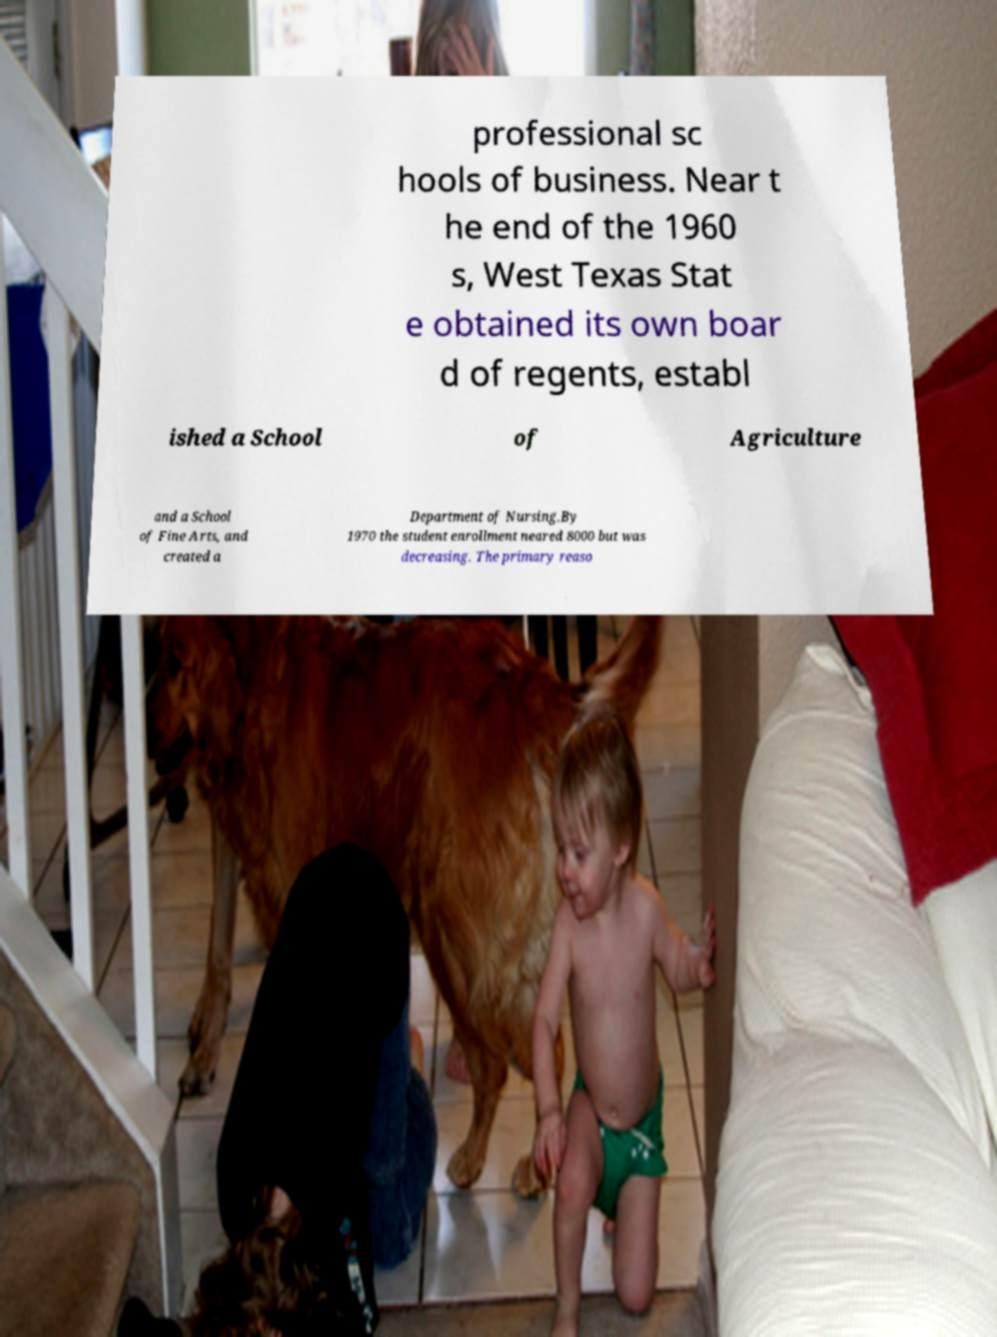What messages or text are displayed in this image? I need them in a readable, typed format. professional sc hools of business. Near t he end of the 1960 s, West Texas Stat e obtained its own boar d of regents, establ ished a School of Agriculture and a School of Fine Arts, and created a Department of Nursing.By 1970 the student enrollment neared 8000 but was decreasing. The primary reaso 